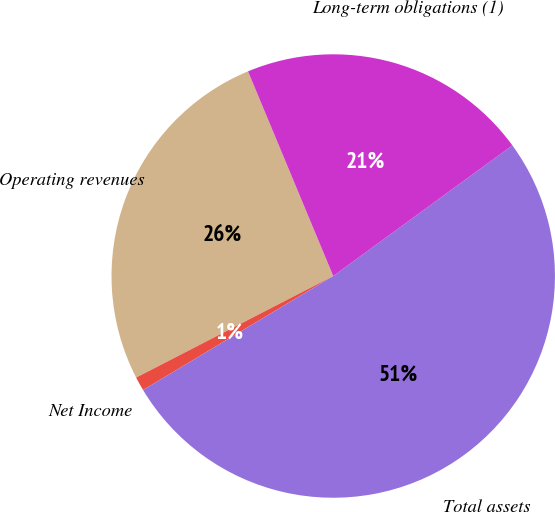Convert chart. <chart><loc_0><loc_0><loc_500><loc_500><pie_chart><fcel>Operating revenues<fcel>Net Income<fcel>Total assets<fcel>Long-term obligations (1)<nl><fcel>26.29%<fcel>1.02%<fcel>51.43%<fcel>21.25%<nl></chart> 